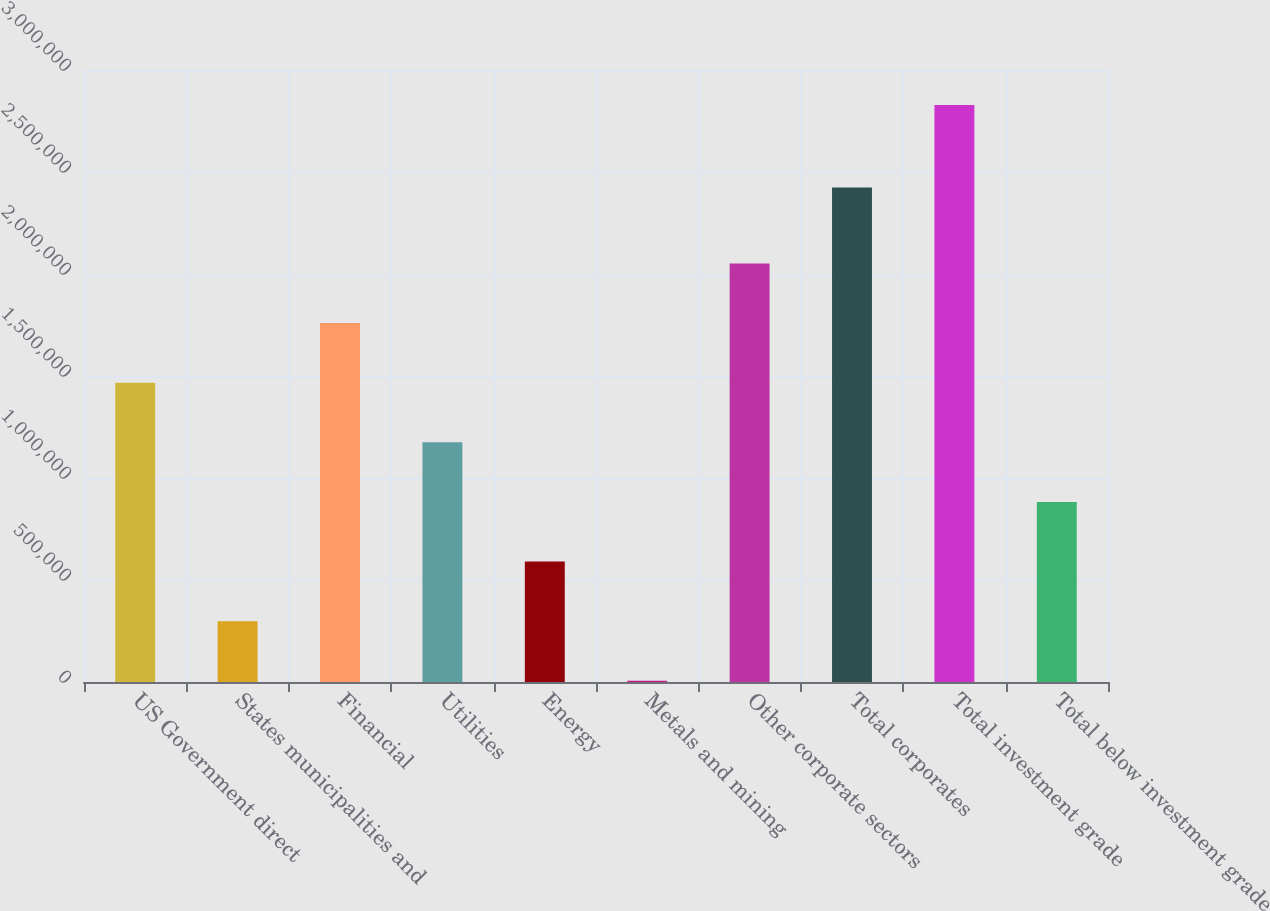Convert chart to OTSL. <chart><loc_0><loc_0><loc_500><loc_500><bar_chart><fcel>US Government direct<fcel>States municipalities and<fcel>Financial<fcel>Utilities<fcel>Energy<fcel>Metals and mining<fcel>Other corporate sectors<fcel>Total corporates<fcel>Total investment grade<fcel>Total below investment grade<nl><fcel>1.46719e+06<fcel>298186<fcel>1.75944e+06<fcel>1.17494e+06<fcel>590437<fcel>5936<fcel>2.05169e+06<fcel>2.42367e+06<fcel>2.82876e+06<fcel>882688<nl></chart> 